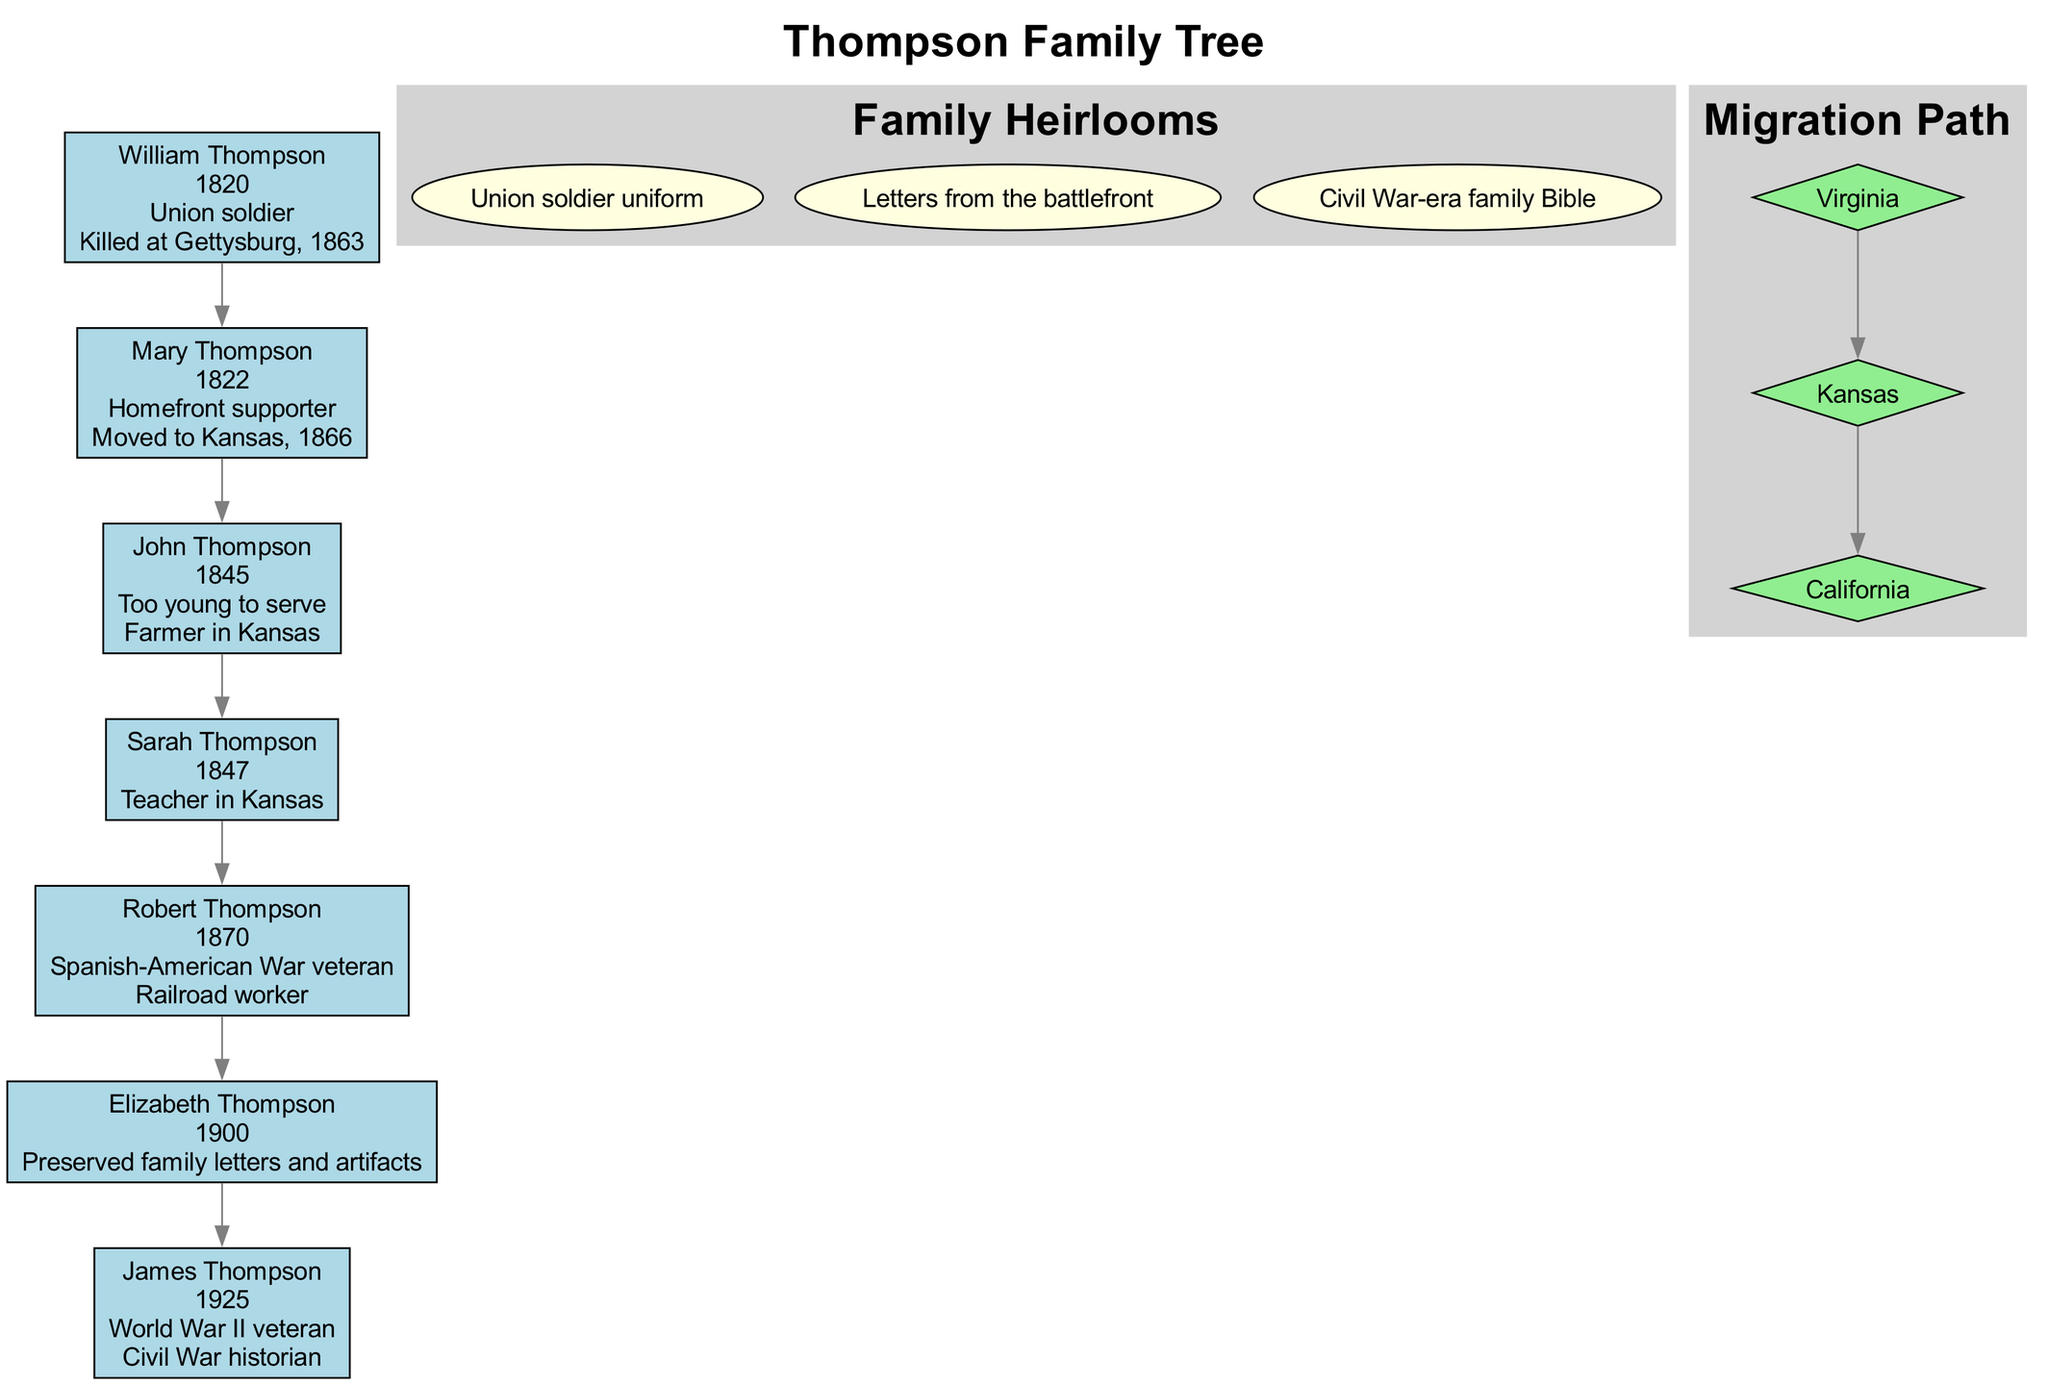What was William Thompson's role during the Civil War? The diagram indicates that William Thompson served as a "Union soldier," which is directly mentioned in his information node.
Answer: Union soldier How many generations does the Thompson family tree represent? By counting the individuals listed in the generations section of the diagram, we find there are seven family members represented, all in different generational segments.
Answer: 7 What did Mary Thompson do after the Civil War? According to the diagram, Mary Thompson's post-war life is described as having "Moved to Kansas, 1866" which explicitly outlines her actions following the war.
Answer: Moved to Kansas, 1866 Which family member preserved Civil War artifacts? The diagram specifies that Elizabeth Thompson is known for her "Civil War legacy" which involves preserving "family letters and artifacts," making her the answer to this question.
Answer: Elizabeth Thompson What significant event resulted in William Thompson's fate? The diagram states that William Thompson was "Killed at Gettysburg, 1863," marking this battle as a pivotal point in his life and providing clarity about his fate in the Civil War context.
Answer: Killed at Gettysburg, 1863 In which state did John Thompson establish his post-war life? The information in the diagram notes that after the Civil War, John Thompson became a "Farmer in Kansas," indicating his post-war settlement in that state.
Answer: Kansas Which war did Robert Thompson serve in? The diagram indicates that Robert Thompson was a "Spanish-American War veteran," which directly answers the question about his military service and aligns with generational military traditions in the family.
Answer: Spanish-American War What is the first location in the Thompson family migration path? By analyzing the migration path section of the diagram, the first mentioned location is "Virginia," indicating it as the starting point of their migration history.
Answer: Virginia How did James Thompson contribute to understanding Civil War history? The diagram states that James Thompson was a "Civil War historian," highlighting his role in documenting and interpreting Civil War history in conjunction with his military service.
Answer: Civil War historian 